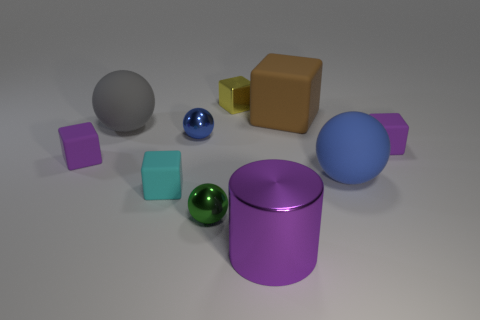Subtract all cyan blocks. How many blocks are left? 4 Subtract all tiny cyan cubes. How many cubes are left? 4 Subtract 1 spheres. How many spheres are left? 3 Subtract all blue blocks. Subtract all cyan cylinders. How many blocks are left? 5 Subtract all cylinders. How many objects are left? 9 Subtract all blue matte balls. Subtract all small purple objects. How many objects are left? 7 Add 7 metallic blocks. How many metallic blocks are left? 8 Add 6 blue matte things. How many blue matte things exist? 7 Subtract 0 red cylinders. How many objects are left? 10 